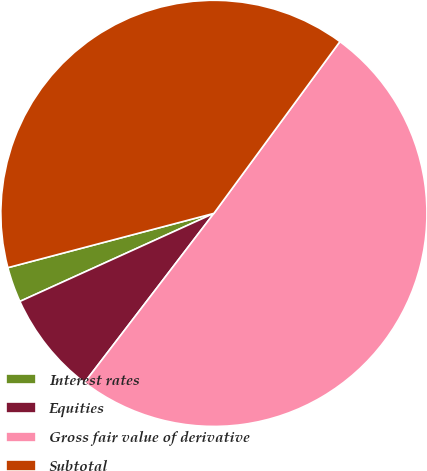<chart> <loc_0><loc_0><loc_500><loc_500><pie_chart><fcel>Interest rates<fcel>Equities<fcel>Gross fair value of derivative<fcel>Subtotal<nl><fcel>2.68%<fcel>7.83%<fcel>50.32%<fcel>39.18%<nl></chart> 